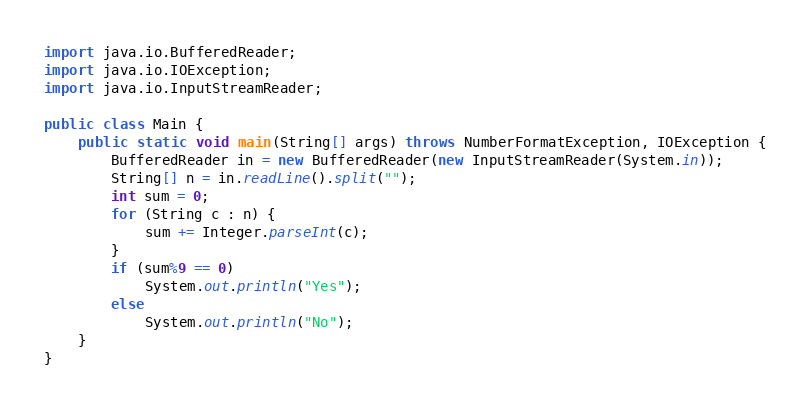<code> <loc_0><loc_0><loc_500><loc_500><_Java_>import java.io.BufferedReader;
import java.io.IOException;
import java.io.InputStreamReader;

public class Main {
	public static void main(String[] args) throws NumberFormatException, IOException {
		BufferedReader in = new BufferedReader(new InputStreamReader(System.in));
		String[] n = in.readLine().split("");
		int sum = 0;
		for (String c : n) {
			sum += Integer.parseInt(c);
		}
		if (sum%9 == 0)
			System.out.println("Yes");
		else
			System.out.println("No");
	}
}
</code> 